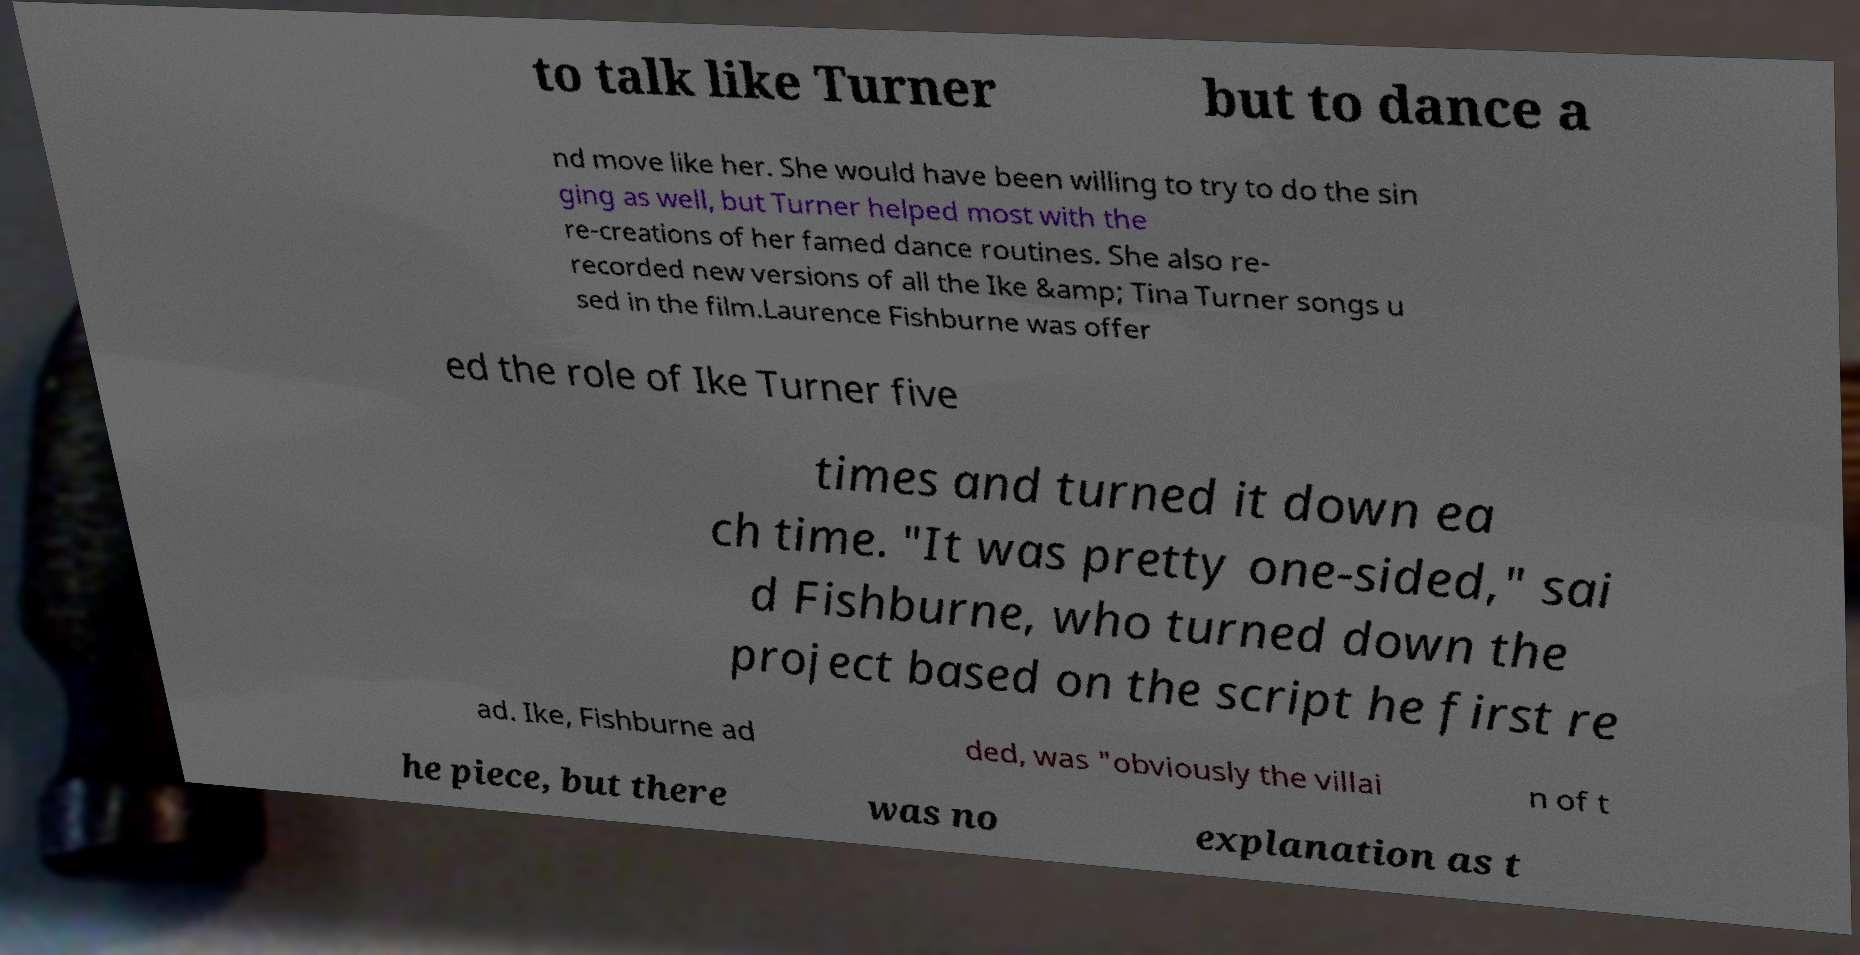For documentation purposes, I need the text within this image transcribed. Could you provide that? to talk like Turner but to dance a nd move like her. She would have been willing to try to do the sin ging as well, but Turner helped most with the re-creations of her famed dance routines. She also re- recorded new versions of all the Ike &amp; Tina Turner songs u sed in the film.Laurence Fishburne was offer ed the role of Ike Turner five times and turned it down ea ch time. "It was pretty one-sided," sai d Fishburne, who turned down the project based on the script he first re ad. Ike, Fishburne ad ded, was "obviously the villai n of t he piece, but there was no explanation as t 